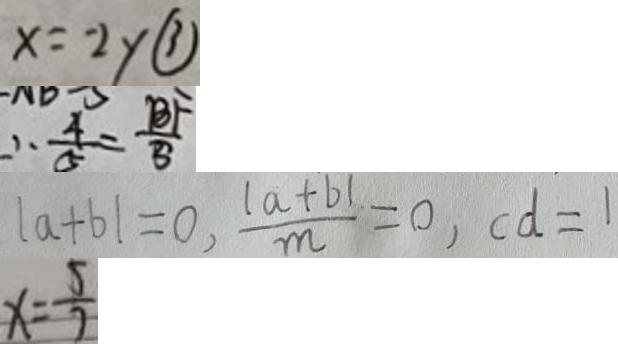<formula> <loc_0><loc_0><loc_500><loc_500>x = - 2 y \textcircled { 3 } 
 \therefore \frac { 4 } { 5 } = \frac { B F } { 5 } 
 \vert a + b \vert = 0 , \frac { \vert a + b \vert } { m } = 0 , c d = 1 
 x = \frac { 5 } { 7 }</formula> 